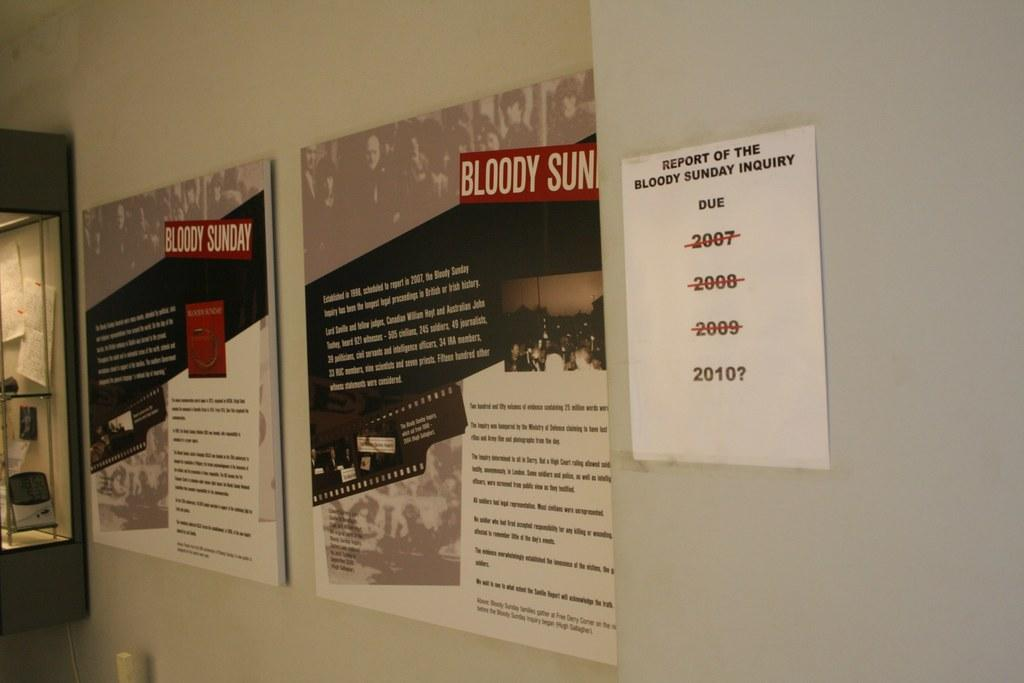<image>
Relay a brief, clear account of the picture shown. a wall with flyers with one that says 'report of the bloody sunday inquiry' 